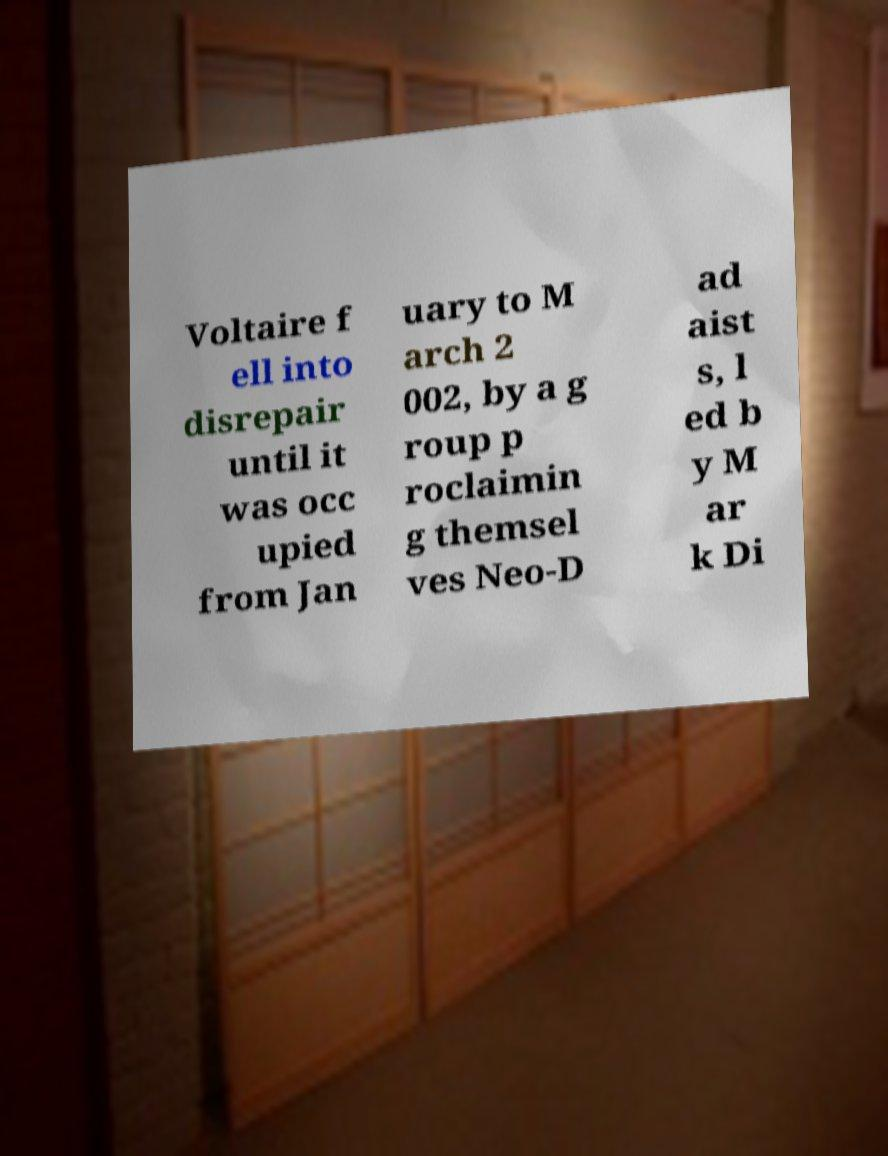Can you read and provide the text displayed in the image?This photo seems to have some interesting text. Can you extract and type it out for me? Voltaire f ell into disrepair until it was occ upied from Jan uary to M arch 2 002, by a g roup p roclaimin g themsel ves Neo-D ad aist s, l ed b y M ar k Di 